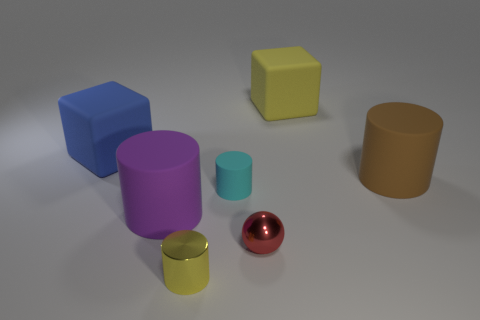The thing that is the same color as the small metal cylinder is what shape?
Your answer should be compact. Cube. How big is the matte cube that is on the left side of the thing behind the rubber cube that is left of the yellow block?
Your answer should be compact. Large. What number of other things are the same material as the tiny ball?
Give a very brief answer. 1. There is a yellow thing in front of the cyan rubber cylinder; what is its size?
Keep it short and to the point. Small. What number of cylinders are behind the shiny ball and in front of the large brown matte cylinder?
Your answer should be very brief. 2. What material is the tiny red thing that is in front of the rubber cube to the left of the purple cylinder?
Your answer should be very brief. Metal. What is the material of the tiny yellow thing that is the same shape as the purple matte object?
Your answer should be compact. Metal. Is there a ball?
Ensure brevity in your answer.  Yes. What shape is the large blue thing that is made of the same material as the cyan cylinder?
Provide a short and direct response. Cube. There is a yellow object in front of the brown cylinder; what is its material?
Give a very brief answer. Metal. 